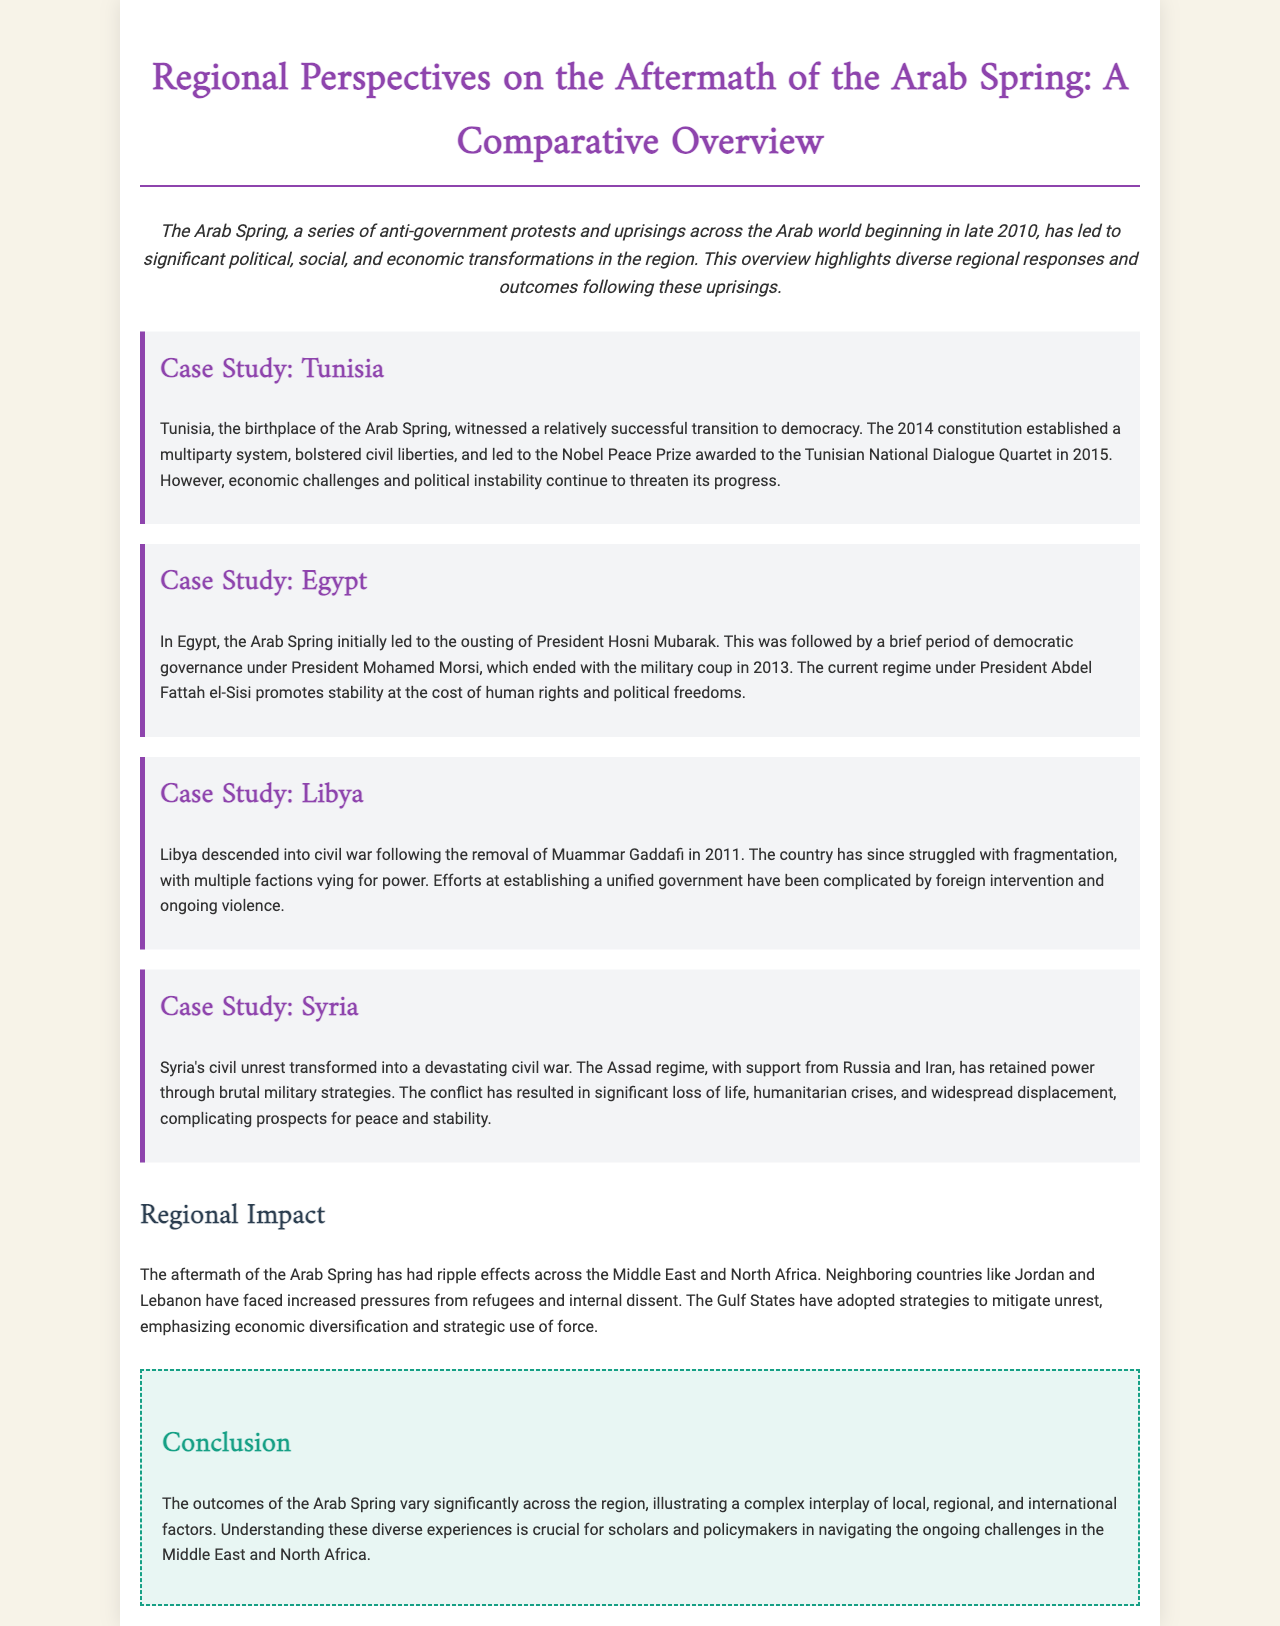What is the title of the brochure? The title is prominently displayed at the top of the document, emphasizing the focus on the Arab Spring.
Answer: Regional Perspectives on the Aftermath of the Arab Spring: A Comparative Overview Which country is referred to as the birthplace of the Arab Spring? The document identifies the initial trigger location for the Arab Spring.
Answer: Tunisia What award did the Tunisian National Dialogue Quartet receive? The document highlights a significant recognition for Tunisia's political dialogue efforts.
Answer: Nobel Peace Prize Who is the current president of Egypt mentioned in the document? The document provides the name of Egypt's leader in the aftermath of the uprisings.
Answer: Abdel Fattah el-Sisi What major crisis is referenced in Syria's aftermath? This reflects the dire humanitarian circumstances that developed due to the civil war.
Answer: Humanitarian crises What has Libya struggled with after the removal of Gaddafi? The document describes the ongoing political and social issues faced by Libya.
Answer: Fragmentation What have Gulf States emphasized post-Arab Spring? This reveals the strategies adopted by these nations to manage unrest in their regions.
Answer: Economic diversification Which two countries are mentioned as facing increased pressures from refugees? These countries are specifically identified due to their geographic and political contexts.
Answer: Jordan and Lebanon What is the overall theme of the brochure? This question relates to the intended purpose and takeaway message of the document.
Answer: Diverse regional responses and outcomes 